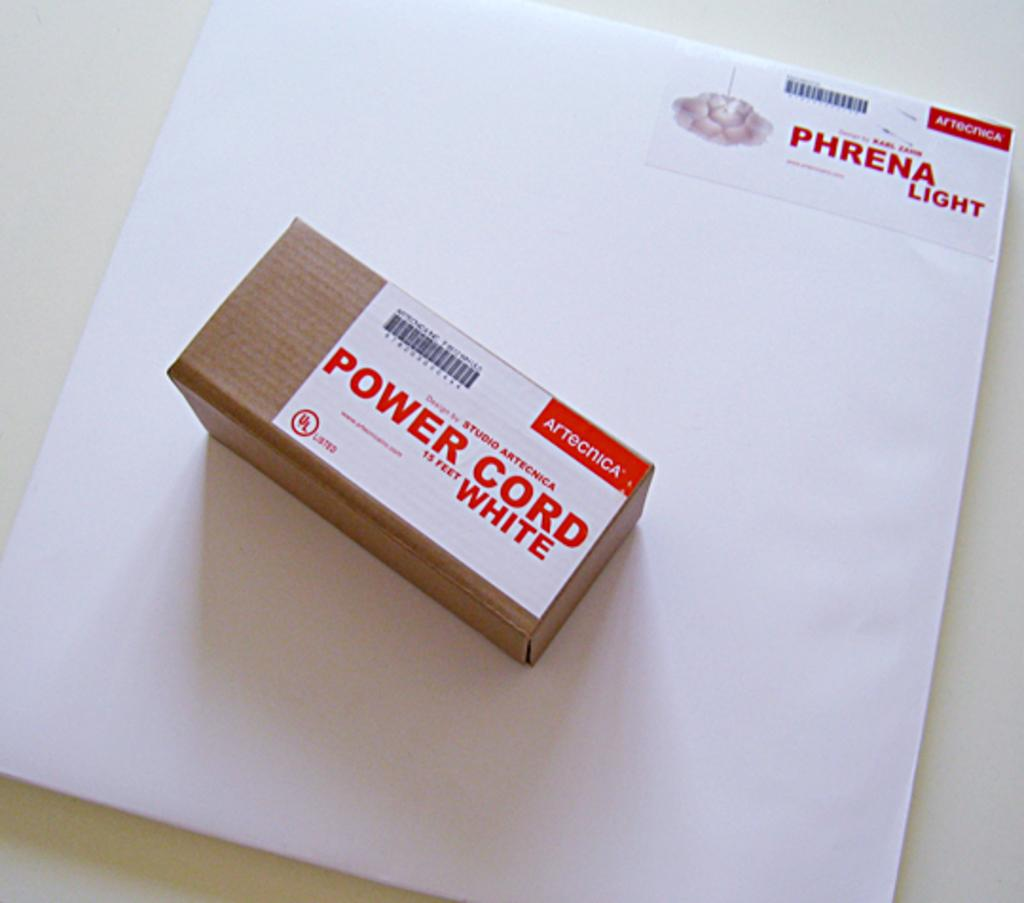Provide a one-sentence caption for the provided image. a box that says 'power cord 15 feet white' on top of a white envelope. 